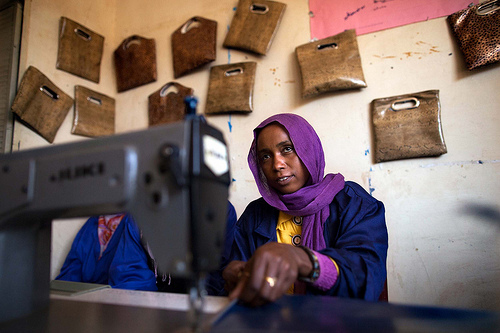<image>
Can you confirm if the woman is in front of the sewing machine? No. The woman is not in front of the sewing machine. The spatial positioning shows a different relationship between these objects. 